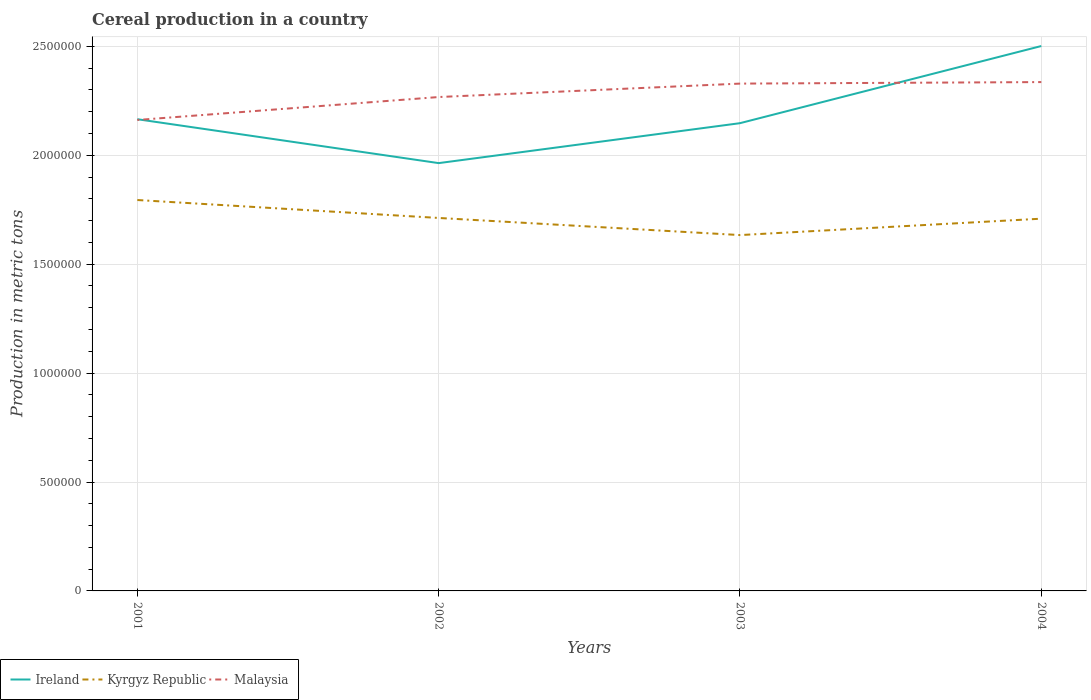Does the line corresponding to Kyrgyz Republic intersect with the line corresponding to Ireland?
Ensure brevity in your answer.  No. Is the number of lines equal to the number of legend labels?
Provide a short and direct response. Yes. Across all years, what is the maximum total cereal production in Ireland?
Your response must be concise. 1.96e+06. In which year was the total cereal production in Kyrgyz Republic maximum?
Give a very brief answer. 2003. What is the total total cereal production in Malaysia in the graph?
Keep it short and to the point. -6.86e+04. What is the difference between the highest and the second highest total cereal production in Ireland?
Ensure brevity in your answer.  5.38e+05. How many lines are there?
Offer a very short reply. 3. How many years are there in the graph?
Your answer should be compact. 4. Does the graph contain grids?
Your response must be concise. Yes. How many legend labels are there?
Give a very brief answer. 3. How are the legend labels stacked?
Provide a short and direct response. Horizontal. What is the title of the graph?
Keep it short and to the point. Cereal production in a country. Does "South Sudan" appear as one of the legend labels in the graph?
Give a very brief answer. No. What is the label or title of the X-axis?
Offer a terse response. Years. What is the label or title of the Y-axis?
Keep it short and to the point. Production in metric tons. What is the Production in metric tons of Ireland in 2001?
Make the answer very short. 2.17e+06. What is the Production in metric tons of Kyrgyz Republic in 2001?
Offer a very short reply. 1.79e+06. What is the Production in metric tons in Malaysia in 2001?
Your answer should be compact. 2.16e+06. What is the Production in metric tons of Ireland in 2002?
Ensure brevity in your answer.  1.96e+06. What is the Production in metric tons of Kyrgyz Republic in 2002?
Offer a very short reply. 1.71e+06. What is the Production in metric tons in Malaysia in 2002?
Your answer should be very brief. 2.27e+06. What is the Production in metric tons of Ireland in 2003?
Keep it short and to the point. 2.15e+06. What is the Production in metric tons in Kyrgyz Republic in 2003?
Provide a succinct answer. 1.63e+06. What is the Production in metric tons in Malaysia in 2003?
Your answer should be very brief. 2.33e+06. What is the Production in metric tons of Ireland in 2004?
Give a very brief answer. 2.50e+06. What is the Production in metric tons of Kyrgyz Republic in 2004?
Ensure brevity in your answer.  1.71e+06. What is the Production in metric tons in Malaysia in 2004?
Provide a succinct answer. 2.34e+06. Across all years, what is the maximum Production in metric tons of Ireland?
Offer a terse response. 2.50e+06. Across all years, what is the maximum Production in metric tons in Kyrgyz Republic?
Your response must be concise. 1.79e+06. Across all years, what is the maximum Production in metric tons of Malaysia?
Provide a short and direct response. 2.34e+06. Across all years, what is the minimum Production in metric tons in Ireland?
Provide a short and direct response. 1.96e+06. Across all years, what is the minimum Production in metric tons of Kyrgyz Republic?
Offer a terse response. 1.63e+06. Across all years, what is the minimum Production in metric tons in Malaysia?
Your answer should be compact. 2.16e+06. What is the total Production in metric tons of Ireland in the graph?
Your response must be concise. 8.78e+06. What is the total Production in metric tons in Kyrgyz Republic in the graph?
Provide a succinct answer. 6.85e+06. What is the total Production in metric tons in Malaysia in the graph?
Your answer should be compact. 9.09e+06. What is the difference between the Production in metric tons in Ireland in 2001 and that in 2002?
Your answer should be very brief. 2.02e+05. What is the difference between the Production in metric tons in Kyrgyz Republic in 2001 and that in 2002?
Your response must be concise. 8.23e+04. What is the difference between the Production in metric tons in Malaysia in 2001 and that in 2002?
Provide a succinct answer. -1.05e+05. What is the difference between the Production in metric tons in Ireland in 2001 and that in 2003?
Ensure brevity in your answer.  1.82e+04. What is the difference between the Production in metric tons of Kyrgyz Republic in 2001 and that in 2003?
Give a very brief answer. 1.61e+05. What is the difference between the Production in metric tons of Malaysia in 2001 and that in 2003?
Your response must be concise. -1.67e+05. What is the difference between the Production in metric tons of Ireland in 2001 and that in 2004?
Your response must be concise. -3.36e+05. What is the difference between the Production in metric tons in Kyrgyz Republic in 2001 and that in 2004?
Give a very brief answer. 8.57e+04. What is the difference between the Production in metric tons in Malaysia in 2001 and that in 2004?
Give a very brief answer. -1.74e+05. What is the difference between the Production in metric tons of Ireland in 2002 and that in 2003?
Give a very brief answer. -1.83e+05. What is the difference between the Production in metric tons of Kyrgyz Republic in 2002 and that in 2003?
Offer a very short reply. 7.86e+04. What is the difference between the Production in metric tons in Malaysia in 2002 and that in 2003?
Give a very brief answer. -6.16e+04. What is the difference between the Production in metric tons of Ireland in 2002 and that in 2004?
Your answer should be compact. -5.38e+05. What is the difference between the Production in metric tons of Kyrgyz Republic in 2002 and that in 2004?
Your answer should be very brief. 3319. What is the difference between the Production in metric tons in Malaysia in 2002 and that in 2004?
Ensure brevity in your answer.  -6.86e+04. What is the difference between the Production in metric tons of Ireland in 2003 and that in 2004?
Your response must be concise. -3.54e+05. What is the difference between the Production in metric tons of Kyrgyz Republic in 2003 and that in 2004?
Provide a succinct answer. -7.53e+04. What is the difference between the Production in metric tons of Malaysia in 2003 and that in 2004?
Provide a short and direct response. -7000. What is the difference between the Production in metric tons of Ireland in 2001 and the Production in metric tons of Kyrgyz Republic in 2002?
Offer a terse response. 4.53e+05. What is the difference between the Production in metric tons of Ireland in 2001 and the Production in metric tons of Malaysia in 2002?
Ensure brevity in your answer.  -1.02e+05. What is the difference between the Production in metric tons in Kyrgyz Republic in 2001 and the Production in metric tons in Malaysia in 2002?
Offer a terse response. -4.73e+05. What is the difference between the Production in metric tons of Ireland in 2001 and the Production in metric tons of Kyrgyz Republic in 2003?
Provide a succinct answer. 5.32e+05. What is the difference between the Production in metric tons of Ireland in 2001 and the Production in metric tons of Malaysia in 2003?
Make the answer very short. -1.63e+05. What is the difference between the Production in metric tons of Kyrgyz Republic in 2001 and the Production in metric tons of Malaysia in 2003?
Your answer should be very brief. -5.34e+05. What is the difference between the Production in metric tons of Ireland in 2001 and the Production in metric tons of Kyrgyz Republic in 2004?
Offer a terse response. 4.57e+05. What is the difference between the Production in metric tons of Ireland in 2001 and the Production in metric tons of Malaysia in 2004?
Keep it short and to the point. -1.70e+05. What is the difference between the Production in metric tons in Kyrgyz Republic in 2001 and the Production in metric tons in Malaysia in 2004?
Keep it short and to the point. -5.41e+05. What is the difference between the Production in metric tons in Ireland in 2002 and the Production in metric tons in Kyrgyz Republic in 2003?
Provide a succinct answer. 3.30e+05. What is the difference between the Production in metric tons in Ireland in 2002 and the Production in metric tons in Malaysia in 2003?
Give a very brief answer. -3.65e+05. What is the difference between the Production in metric tons of Kyrgyz Republic in 2002 and the Production in metric tons of Malaysia in 2003?
Offer a terse response. -6.17e+05. What is the difference between the Production in metric tons of Ireland in 2002 and the Production in metric tons of Kyrgyz Republic in 2004?
Keep it short and to the point. 2.55e+05. What is the difference between the Production in metric tons of Ireland in 2002 and the Production in metric tons of Malaysia in 2004?
Ensure brevity in your answer.  -3.72e+05. What is the difference between the Production in metric tons of Kyrgyz Republic in 2002 and the Production in metric tons of Malaysia in 2004?
Your answer should be compact. -6.24e+05. What is the difference between the Production in metric tons of Ireland in 2003 and the Production in metric tons of Kyrgyz Republic in 2004?
Keep it short and to the point. 4.38e+05. What is the difference between the Production in metric tons of Ireland in 2003 and the Production in metric tons of Malaysia in 2004?
Your answer should be compact. -1.89e+05. What is the difference between the Production in metric tons in Kyrgyz Republic in 2003 and the Production in metric tons in Malaysia in 2004?
Your answer should be compact. -7.02e+05. What is the average Production in metric tons in Ireland per year?
Your response must be concise. 2.19e+06. What is the average Production in metric tons in Kyrgyz Republic per year?
Your answer should be compact. 1.71e+06. What is the average Production in metric tons of Malaysia per year?
Provide a succinct answer. 2.27e+06. In the year 2001, what is the difference between the Production in metric tons of Ireland and Production in metric tons of Kyrgyz Republic?
Give a very brief answer. 3.71e+05. In the year 2001, what is the difference between the Production in metric tons in Ireland and Production in metric tons in Malaysia?
Provide a succinct answer. 3547. In the year 2001, what is the difference between the Production in metric tons of Kyrgyz Republic and Production in metric tons of Malaysia?
Make the answer very short. -3.67e+05. In the year 2002, what is the difference between the Production in metric tons of Ireland and Production in metric tons of Kyrgyz Republic?
Your response must be concise. 2.52e+05. In the year 2002, what is the difference between the Production in metric tons in Ireland and Production in metric tons in Malaysia?
Ensure brevity in your answer.  -3.03e+05. In the year 2002, what is the difference between the Production in metric tons of Kyrgyz Republic and Production in metric tons of Malaysia?
Your answer should be very brief. -5.55e+05. In the year 2003, what is the difference between the Production in metric tons in Ireland and Production in metric tons in Kyrgyz Republic?
Ensure brevity in your answer.  5.14e+05. In the year 2003, what is the difference between the Production in metric tons of Ireland and Production in metric tons of Malaysia?
Your answer should be compact. -1.82e+05. In the year 2003, what is the difference between the Production in metric tons of Kyrgyz Republic and Production in metric tons of Malaysia?
Offer a very short reply. -6.95e+05. In the year 2004, what is the difference between the Production in metric tons of Ireland and Production in metric tons of Kyrgyz Republic?
Offer a terse response. 7.93e+05. In the year 2004, what is the difference between the Production in metric tons in Ireland and Production in metric tons in Malaysia?
Your answer should be very brief. 1.66e+05. In the year 2004, what is the difference between the Production in metric tons of Kyrgyz Republic and Production in metric tons of Malaysia?
Your answer should be compact. -6.27e+05. What is the ratio of the Production in metric tons of Ireland in 2001 to that in 2002?
Give a very brief answer. 1.1. What is the ratio of the Production in metric tons in Kyrgyz Republic in 2001 to that in 2002?
Offer a very short reply. 1.05. What is the ratio of the Production in metric tons in Malaysia in 2001 to that in 2002?
Offer a very short reply. 0.95. What is the ratio of the Production in metric tons of Ireland in 2001 to that in 2003?
Ensure brevity in your answer.  1.01. What is the ratio of the Production in metric tons of Kyrgyz Republic in 2001 to that in 2003?
Keep it short and to the point. 1.1. What is the ratio of the Production in metric tons of Malaysia in 2001 to that in 2003?
Your response must be concise. 0.93. What is the ratio of the Production in metric tons in Ireland in 2001 to that in 2004?
Your response must be concise. 0.87. What is the ratio of the Production in metric tons in Kyrgyz Republic in 2001 to that in 2004?
Offer a terse response. 1.05. What is the ratio of the Production in metric tons of Malaysia in 2001 to that in 2004?
Offer a terse response. 0.93. What is the ratio of the Production in metric tons of Ireland in 2002 to that in 2003?
Give a very brief answer. 0.91. What is the ratio of the Production in metric tons in Kyrgyz Republic in 2002 to that in 2003?
Your answer should be compact. 1.05. What is the ratio of the Production in metric tons of Malaysia in 2002 to that in 2003?
Ensure brevity in your answer.  0.97. What is the ratio of the Production in metric tons of Ireland in 2002 to that in 2004?
Make the answer very short. 0.79. What is the ratio of the Production in metric tons in Kyrgyz Republic in 2002 to that in 2004?
Make the answer very short. 1. What is the ratio of the Production in metric tons of Malaysia in 2002 to that in 2004?
Your answer should be compact. 0.97. What is the ratio of the Production in metric tons of Ireland in 2003 to that in 2004?
Your answer should be compact. 0.86. What is the ratio of the Production in metric tons of Kyrgyz Republic in 2003 to that in 2004?
Your answer should be compact. 0.96. What is the difference between the highest and the second highest Production in metric tons of Ireland?
Give a very brief answer. 3.36e+05. What is the difference between the highest and the second highest Production in metric tons of Kyrgyz Republic?
Provide a short and direct response. 8.23e+04. What is the difference between the highest and the second highest Production in metric tons in Malaysia?
Your answer should be compact. 7000. What is the difference between the highest and the lowest Production in metric tons in Ireland?
Provide a succinct answer. 5.38e+05. What is the difference between the highest and the lowest Production in metric tons in Kyrgyz Republic?
Make the answer very short. 1.61e+05. What is the difference between the highest and the lowest Production in metric tons of Malaysia?
Provide a succinct answer. 1.74e+05. 